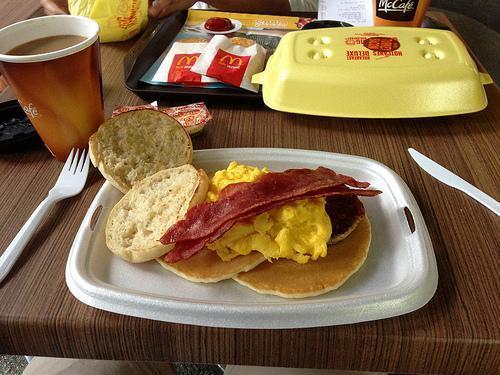How many hashbrowns are shown in this image?
Give a very brief answer. 2. How many forks are shown?
Give a very brief answer. 1. 